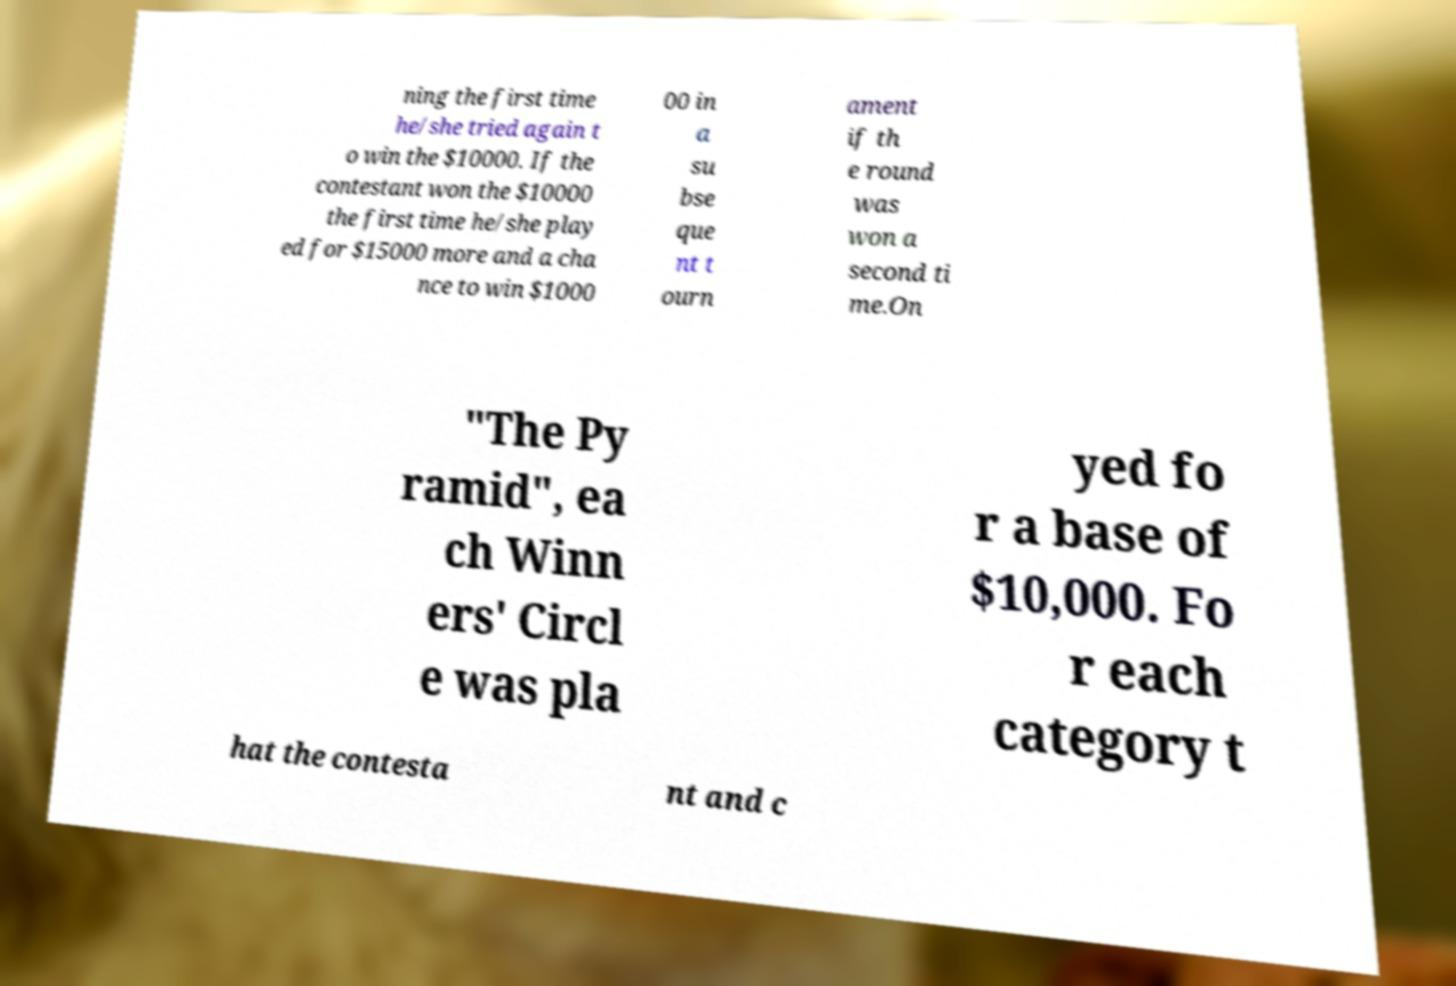There's text embedded in this image that I need extracted. Can you transcribe it verbatim? ning the first time he/she tried again t o win the $10000. If the contestant won the $10000 the first time he/she play ed for $15000 more and a cha nce to win $1000 00 in a su bse que nt t ourn ament if th e round was won a second ti me.On "The Py ramid", ea ch Winn ers' Circl e was pla yed fo r a base of $10,000. Fo r each category t hat the contesta nt and c 